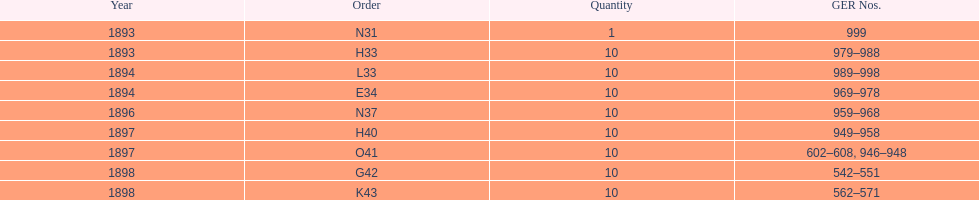What is the aggregate amount of locomotives manufactured during this time? 81. 